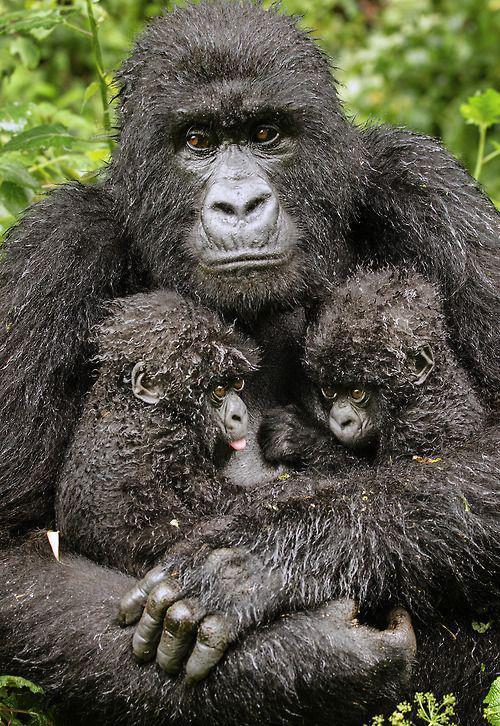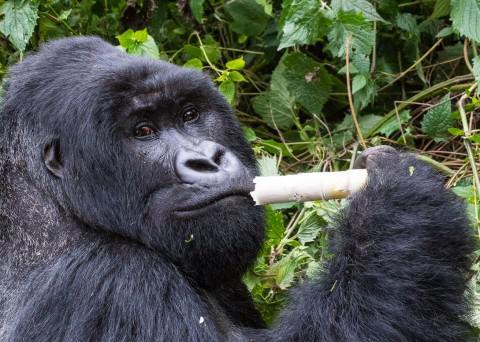The first image is the image on the left, the second image is the image on the right. Considering the images on both sides, is "No image contains more than one gorilla, and each gorilla is gazing in a way that its eyes are visible." valid? Answer yes or no. No. The first image is the image on the left, the second image is the image on the right. Assess this claim about the two images: "The ape on the right is eating something.". Correct or not? Answer yes or no. Yes. 